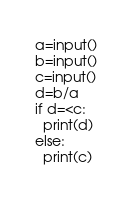<code> <loc_0><loc_0><loc_500><loc_500><_Python_>a=input()
b=input()
c=input()
d=b/a
if d=<c:
  print(d)
else:
  print(c)</code> 